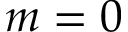<formula> <loc_0><loc_0><loc_500><loc_500>m = 0</formula> 